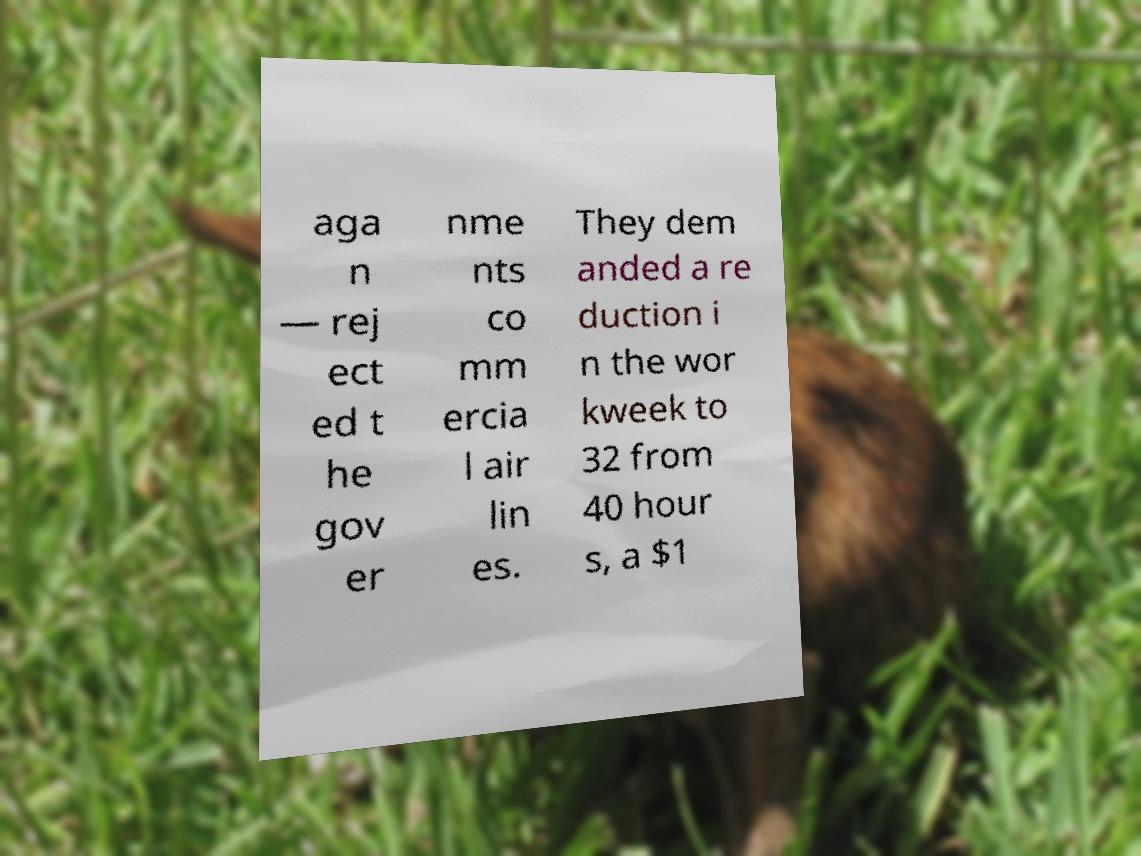Please identify and transcribe the text found in this image. aga n — rej ect ed t he gov er nme nts co mm ercia l air lin es. They dem anded a re duction i n the wor kweek to 32 from 40 hour s, a $1 